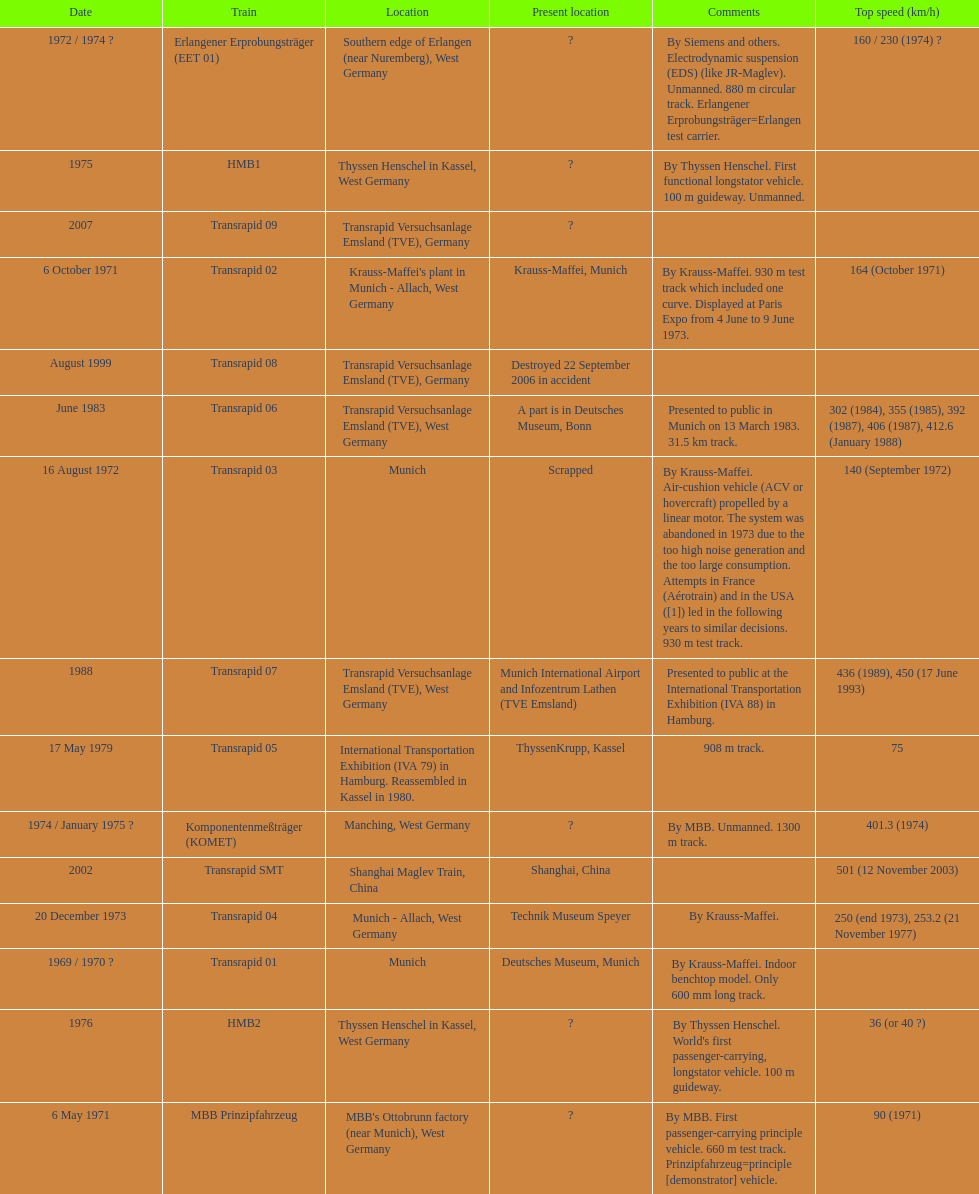Which train has the least top speed? HMB2. 